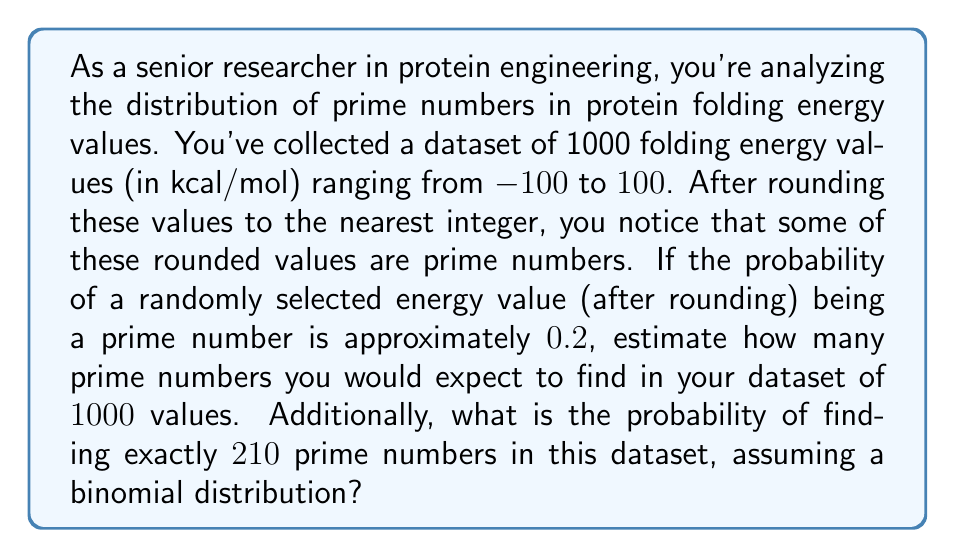Can you answer this question? To solve this problem, we need to use concepts from probability theory, specifically the binomial distribution.

1. Expected number of prime numbers:
   The expected number of successes in a binomial distribution is given by $n * p$, where $n$ is the number of trials and $p$ is the probability of success on each trial.

   In this case:
   $n = 1000$ (total number of energy values)
   $p = 0.2$ (probability of a value being prime)

   Expected number of primes = $1000 * 0.2 = 200$

2. Probability of finding exactly 210 prime numbers:
   We can use the binomial probability mass function:

   $$P(X = k) = \binom{n}{k} p^k (1-p)^{n-k}$$

   Where:
   $n = 1000$ (number of trials)
   $k = 210$ (number of successes we're interested in)
   $p = 0.2$ (probability of success on each trial)

   Substituting these values:

   $$P(X = 210) = \binom{1000}{210} (0.2)^{210} (0.8)^{790}$$

   To calculate this:

   a) First, compute the binomial coefficient:
      $$\binom{1000}{210} = \frac{1000!}{210!(1000-210)!} = \frac{1000!}{210!790!}$$

   b) Then, calculate the powers:
      $(0.2)^{210} = 1.024 * 10^{-146}$
      $(0.8)^{790} = 1.461 * 10^{-102}$

   c) Multiply all parts together:
      $$P(X = 210) = \frac{1000!}{210!790!} * 1.024 * 10^{-146} * 1.461 * 10^{-102}$$

   d) Simplify and compute the final result:
      $$P(X = 210) \approx 0.0267$$
Answer: The expected number of prime numbers in the dataset is 200. The probability of finding exactly 210 prime numbers in this dataset, assuming a binomial distribution, is approximately 0.0267 or 2.67%. 